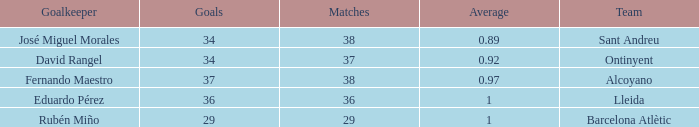What is the total number of goals scored when the number of matches is less than 29? None. 